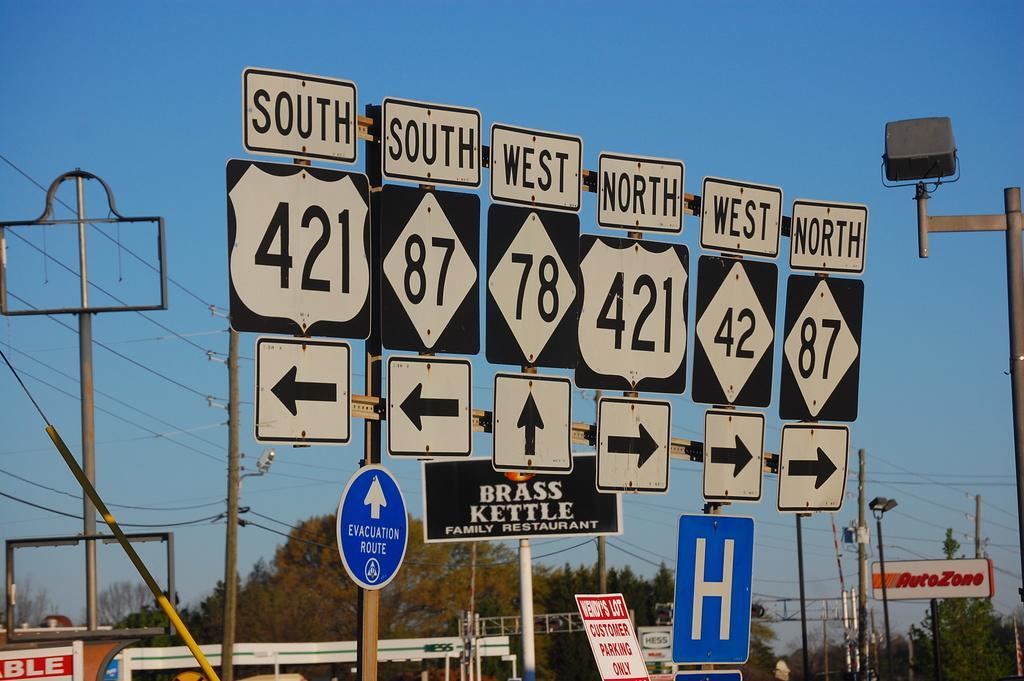<image>
Summarize the visual content of the image. A sign that says BRASS KETTLE FAMILY RESTAURANT is behind route direction signs. 